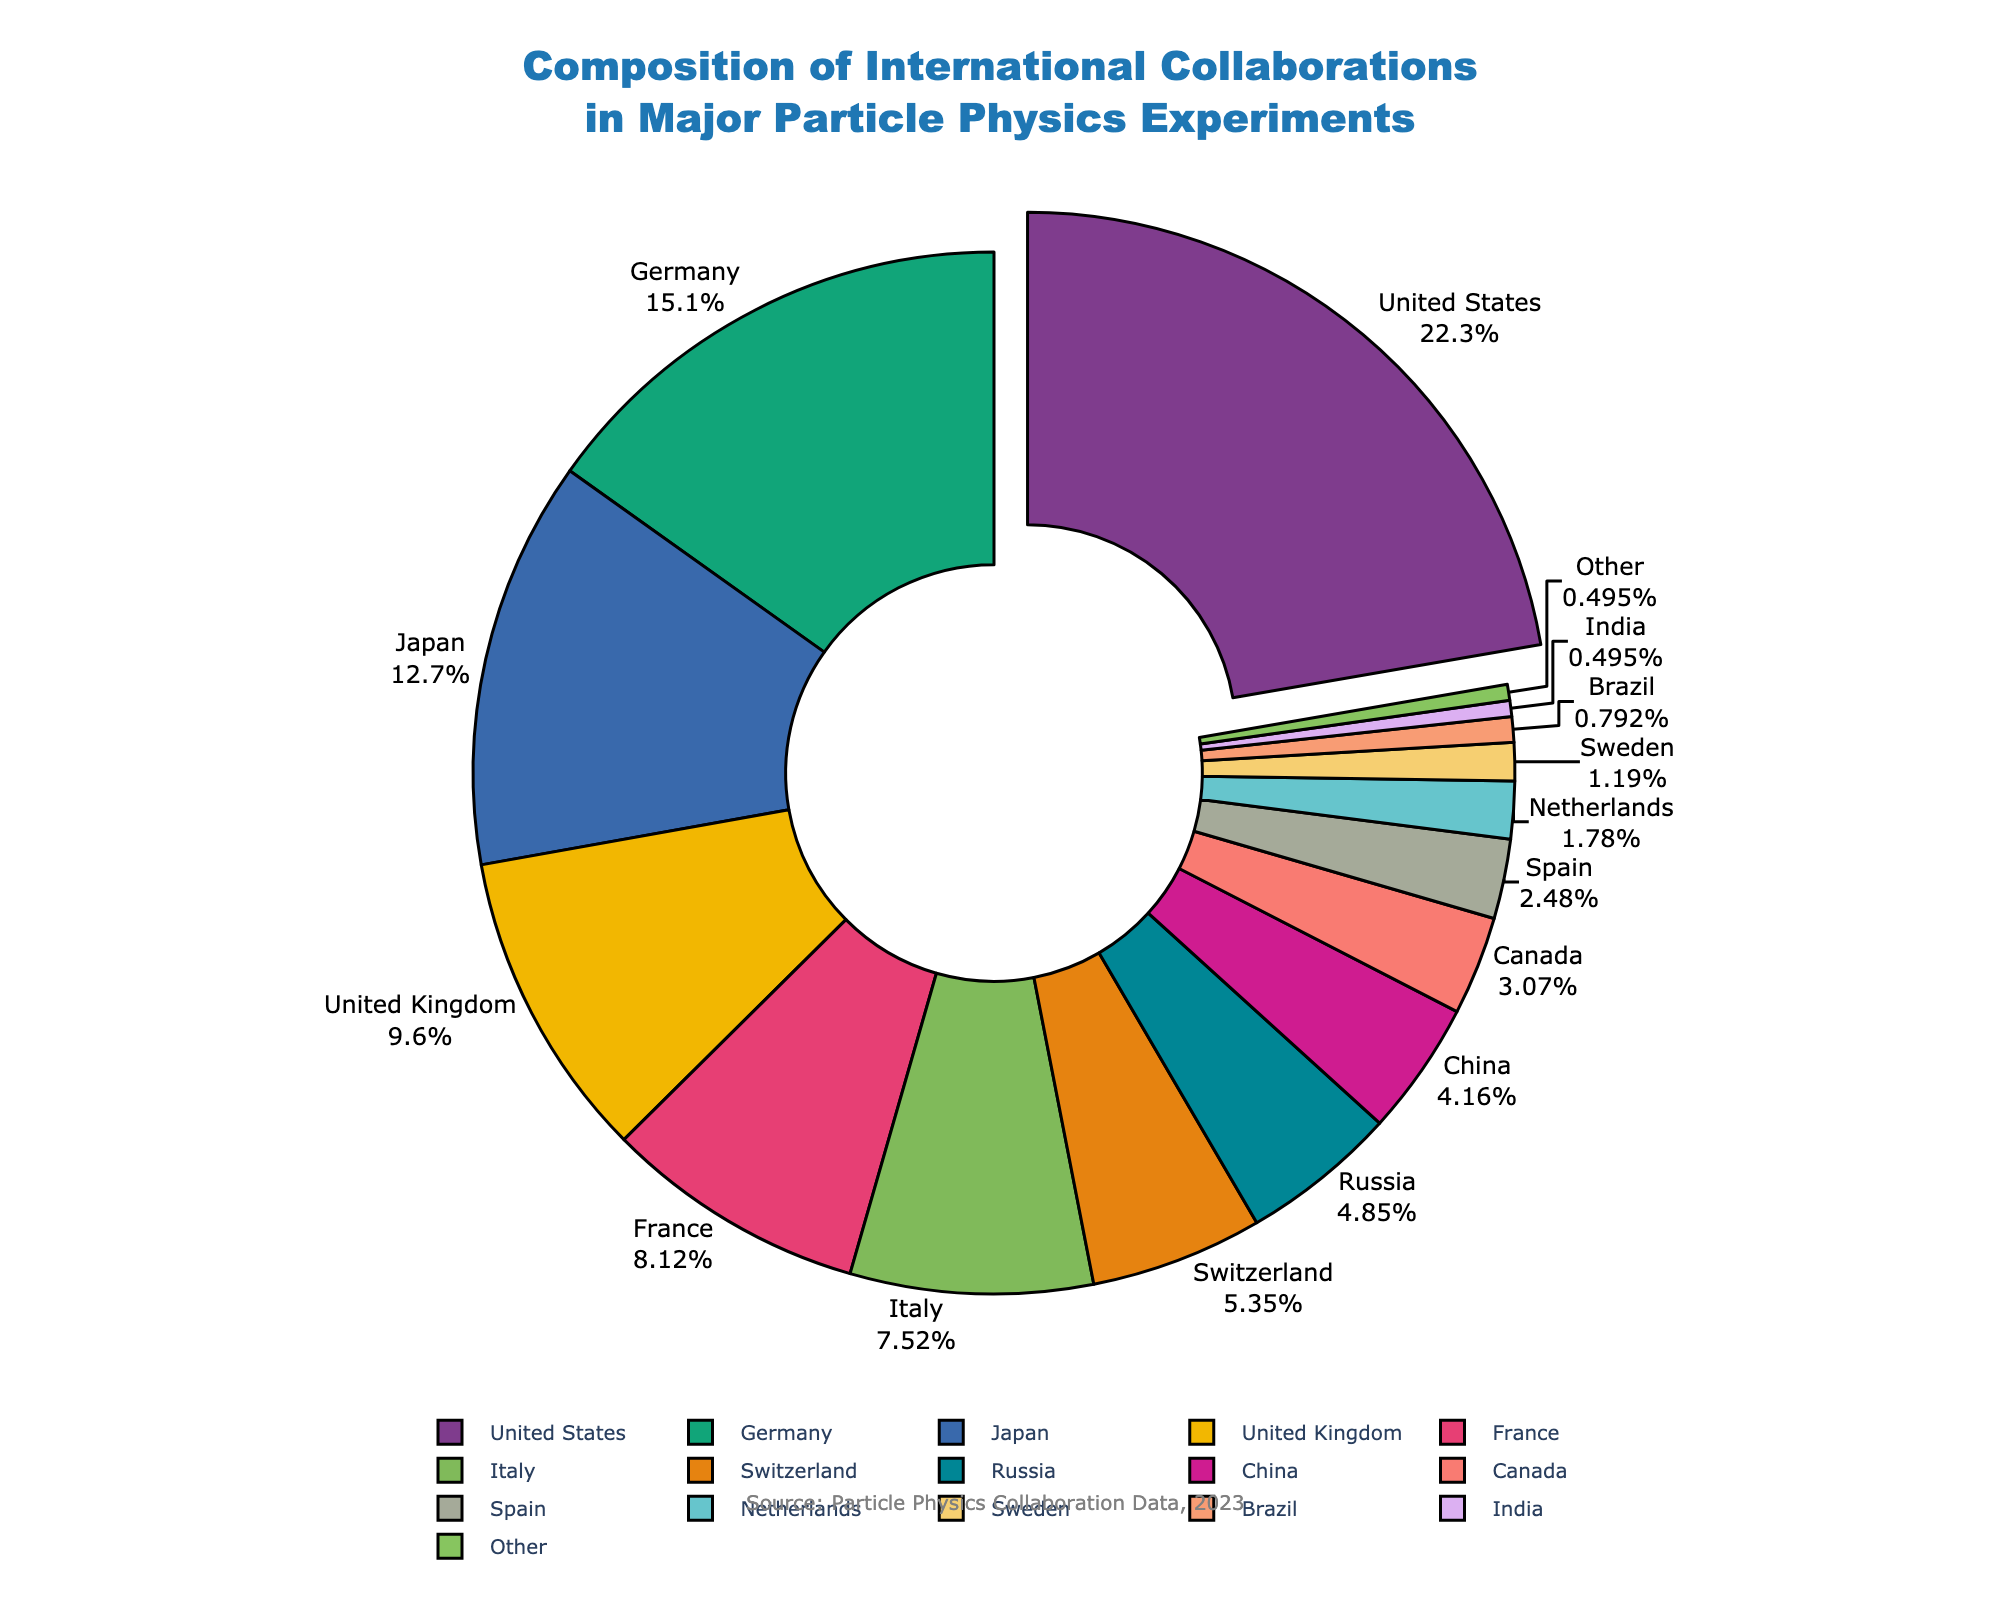Which country has the highest percentage in the international collaborations? The country with the highest percentage will appear as the most prominent slice in the pie chart and may have an offset to emphasize it further. In this case, the United States has the largest slice with 22.5%.
Answer: United States How does the percentage of Germany compare to Japan? Locate the slices for Germany and Japan in the pie chart and compare their sizes or their displayed percentages. Germany has a higher percentage (15.3%) compared to Japan (12.8%).
Answer: Germany is higher What is the combined percentage of the United Kingdom and France? Sum the percentages for the United Kingdom and France. UK: 9.7%, France: 8.2%. The combined percentage is 9.7% + 8.2% = 17.9%.
Answer: 17.9% Which countries have a percentage of less than 1%? Look for slices with percentages less than 1% in the pie chart. Brazil and India both have percentages less than 1% (0.8% and 0.5%, respectively).
Answer: Brazil, India By how much does the percentage of Italy exceed that of Russia? Subtract Russia's percentage from Italy's percentage (Italy: 7.6%, Russia: 4.9%). The difference is 7.6% - 4.9% = 2.7%.
Answer: 2.7% What is the total percentage of contributions from the top three countries? Sum the percentages of the top three countries (United States: 22.5%, Germany: 15.3%, Japan: 12.8%). The total is 22.5% + 15.3% + 12.8% = 50.6%.
Answer: 50.6% Which country represents the smallest visible slice in the pie chart? Identify the smallest slice by comparing the sizes of all slices. India contributes 0.5%, which is the smallest visible slice.
Answer: India What is the average percentage of the contributions from the United States, Germany, and Japan? Calculate the average of the percentages for these countries (United States: 22.5%, Germany: 15.3%, Japan: 12.8%). The average is (22.5% + 15.3% + 12.8%) / 3 = 16.87%.
Answer: 16.87% How do the contributions of Canada and Switzerland compare visually? Visually compare the size of the slices for Canada (3.1%) and Switzerland (5.4%). Switzerland has a larger slice compared to Canada.
Answer: Switzerland is larger What color represents Italy in the pie chart? Identify Italy's slice and note its color from the custom color palette used. The exact color might vary, but it should be distinct and labeled for Italy.
Answer: The specific color (depends on the palette) 